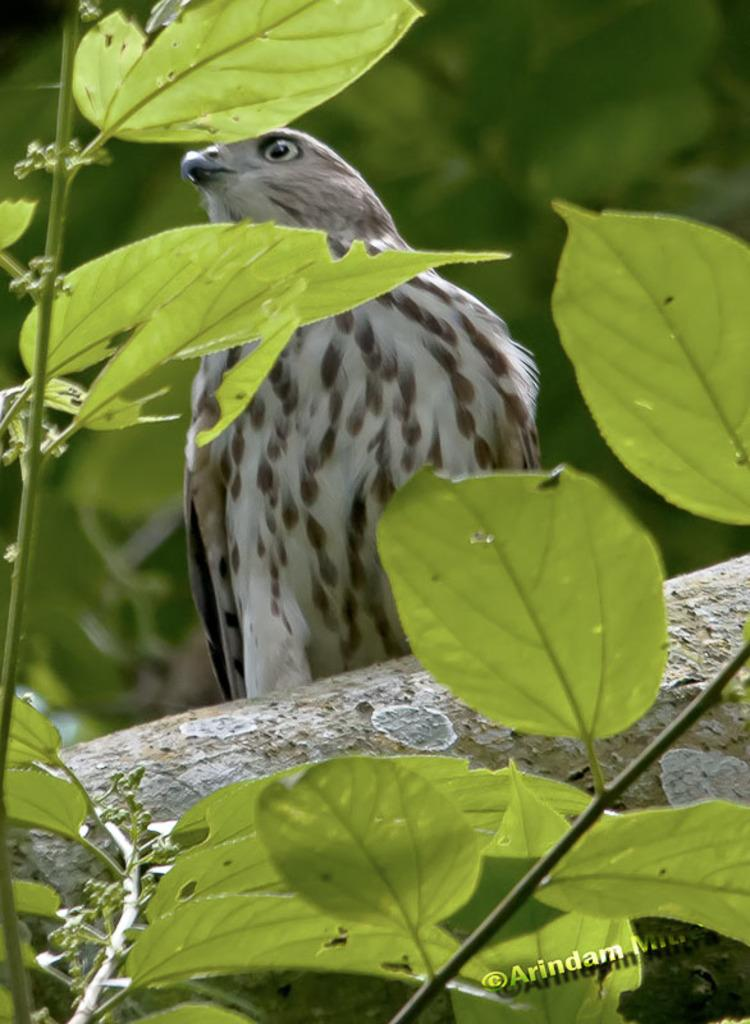What is the main subject in the image? There is a tree in the image. Is there anything on the tree? Yes, there is an eagle on the tree. Can you describe the background of the image? The background of the image is blurred. Is there any text in the image? Yes, there is text in the bottom right corner of the image. How many sheep can be seen grazing near the tree in the image? There are no sheep present in the image; it features a tree with an eagle on it. What type of shoe is hanging from the tree in the image? There is no shoe hanging from the tree in the image; it only features a tree and an eagle. 